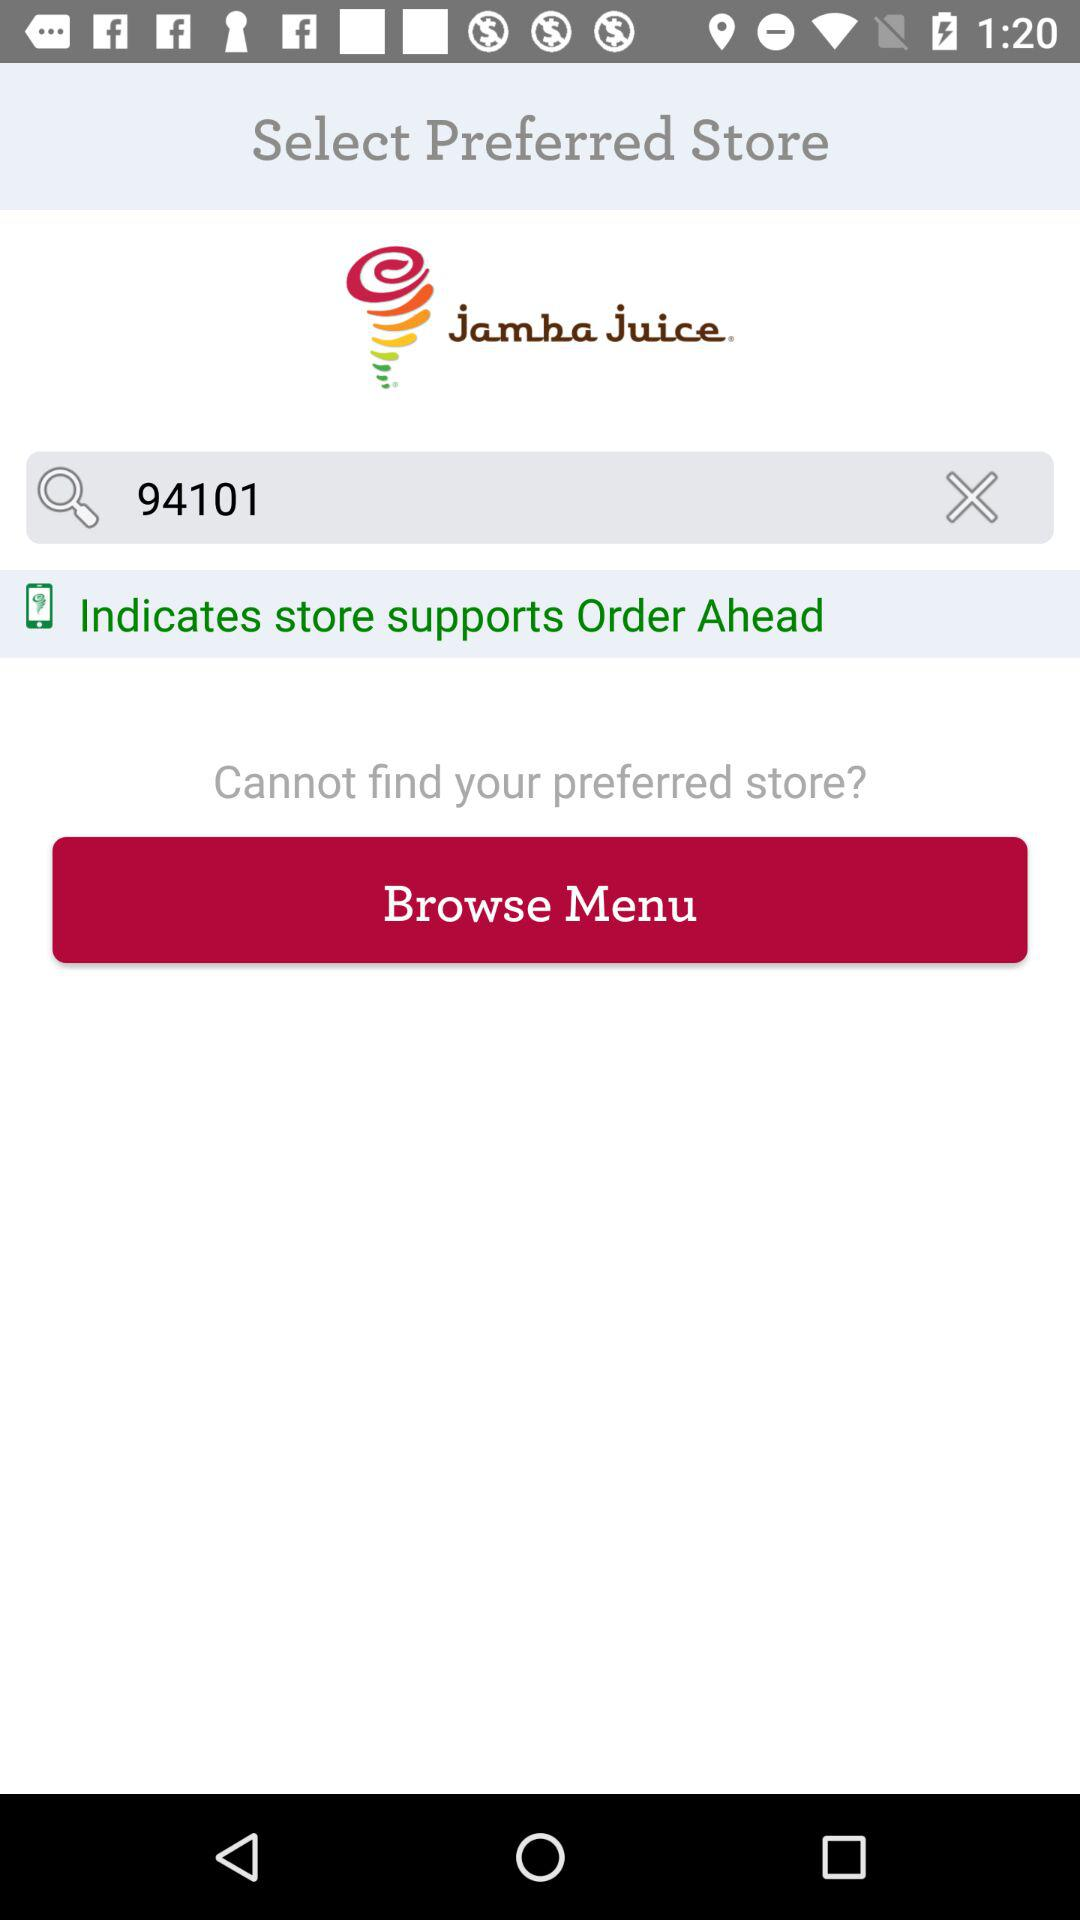What code is entered in the search bar? The code entered in the search bar is 94101. 